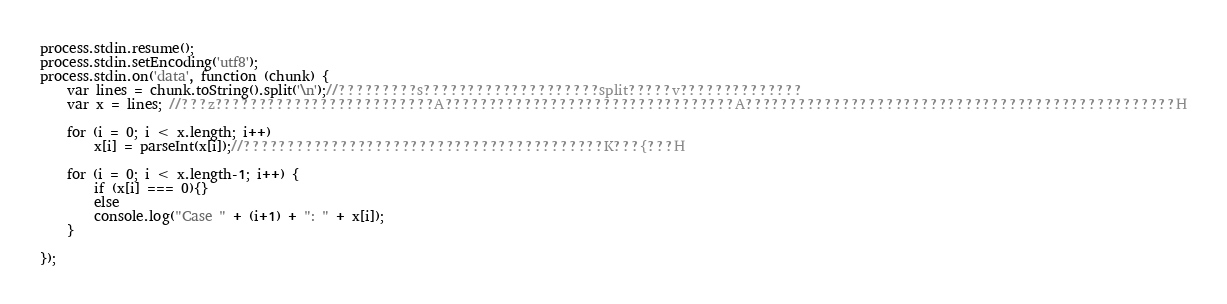<code> <loc_0><loc_0><loc_500><loc_500><_JavaScript_>process.stdin.resume();
process.stdin.setEncoding('utf8');
process.stdin.on('data', function (chunk) {
    var lines = chunk.toString().split('\n');//?????????s????????????????????split?????v??????????????
    var x = lines; //???z?????????????????????????A?????????????????????????????????A?????????????????????????????????????????????????H

    for (i = 0; i < x.length; i++)
        x[i] = parseInt(x[i]);//?????????????????????????????????????????K???{???H

    for (i = 0; i < x.length-1; i++) {
        if (x[i] === 0){}
        else
        console.log("Case " + (i+1) + ": " + x[i]);
    }

});</code> 